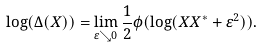Convert formula to latex. <formula><loc_0><loc_0><loc_500><loc_500>\log ( \Delta ( X ) ) = \lim _ { \varepsilon \searrow 0 } \frac { 1 } { 2 } \phi ( \log ( X X ^ { \ast } + \varepsilon ^ { 2 } ) ) .</formula> 